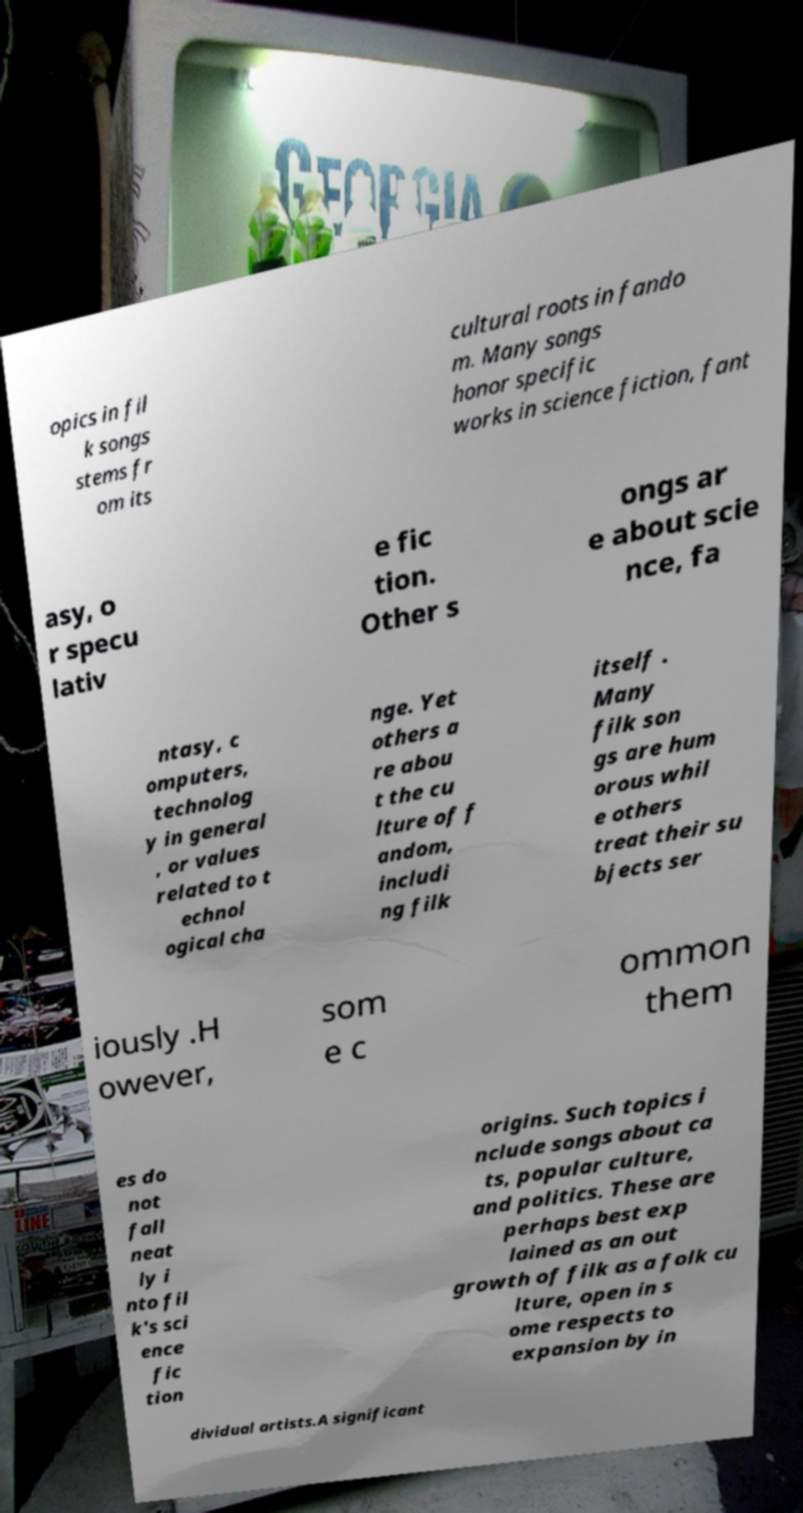Can you accurately transcribe the text from the provided image for me? opics in fil k songs stems fr om its cultural roots in fando m. Many songs honor specific works in science fiction, fant asy, o r specu lativ e fic tion. Other s ongs ar e about scie nce, fa ntasy, c omputers, technolog y in general , or values related to t echnol ogical cha nge. Yet others a re abou t the cu lture of f andom, includi ng filk itself . Many filk son gs are hum orous whil e others treat their su bjects ser iously .H owever, som e c ommon them es do not fall neat ly i nto fil k's sci ence fic tion origins. Such topics i nclude songs about ca ts, popular culture, and politics. These are perhaps best exp lained as an out growth of filk as a folk cu lture, open in s ome respects to expansion by in dividual artists.A significant 